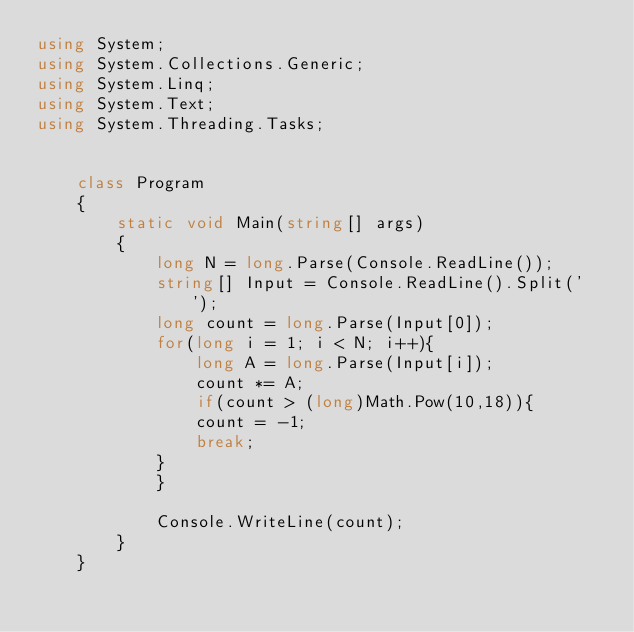<code> <loc_0><loc_0><loc_500><loc_500><_C#_>using System;
using System.Collections.Generic;
using System.Linq;
using System.Text;
using System.Threading.Tasks;


    class Program
    {
        static void Main(string[] args)
        {
            long N = long.Parse(Console.ReadLine());
            string[] Input = Console.ReadLine().Split(' ');
            long count = long.Parse(Input[0]);
            for(long i = 1; i < N; i++){
                long A = long.Parse(Input[i]);
                count *= A;
                if(count > (long)Math.Pow(10,18)){
                count = -1;
                break;
            }
            }
            
            Console.WriteLine(count);
        }
    }
</code> 